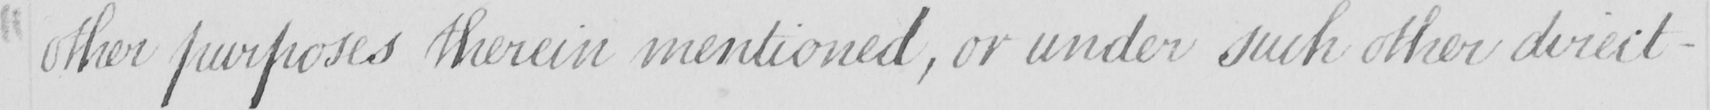What does this handwritten line say? other purposes therein mentioned , or under such other direct- 